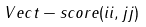<formula> <loc_0><loc_0><loc_500><loc_500>V e c t - s c o r e ( i i , j j ) &</formula> 